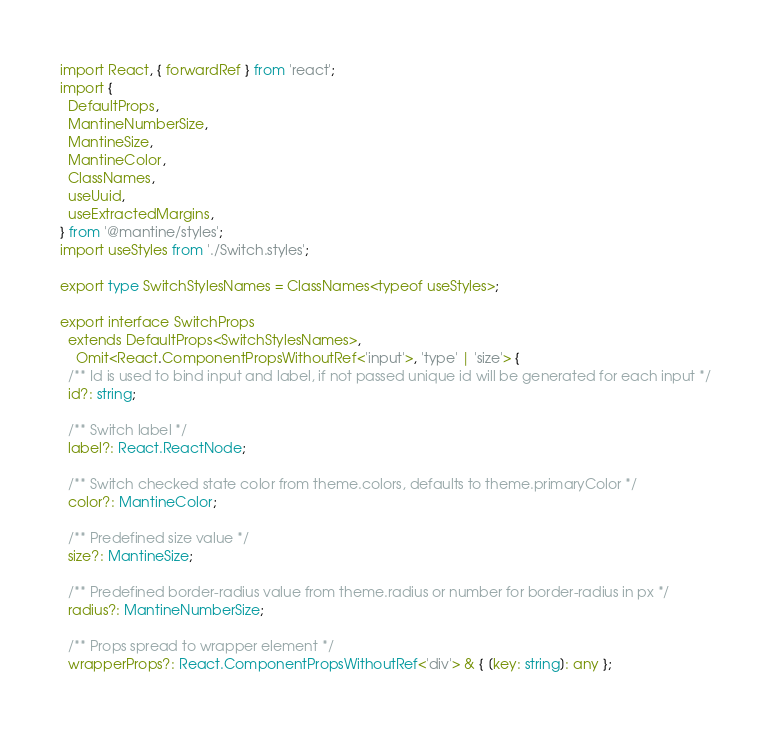<code> <loc_0><loc_0><loc_500><loc_500><_TypeScript_>import React, { forwardRef } from 'react';
import {
  DefaultProps,
  MantineNumberSize,
  MantineSize,
  MantineColor,
  ClassNames,
  useUuid,
  useExtractedMargins,
} from '@mantine/styles';
import useStyles from './Switch.styles';

export type SwitchStylesNames = ClassNames<typeof useStyles>;

export interface SwitchProps
  extends DefaultProps<SwitchStylesNames>,
    Omit<React.ComponentPropsWithoutRef<'input'>, 'type' | 'size'> {
  /** Id is used to bind input and label, if not passed unique id will be generated for each input */
  id?: string;

  /** Switch label */
  label?: React.ReactNode;

  /** Switch checked state color from theme.colors, defaults to theme.primaryColor */
  color?: MantineColor;

  /** Predefined size value */
  size?: MantineSize;

  /** Predefined border-radius value from theme.radius or number for border-radius in px */
  radius?: MantineNumberSize;

  /** Props spread to wrapper element */
  wrapperProps?: React.ComponentPropsWithoutRef<'div'> & { [key: string]: any };</code> 